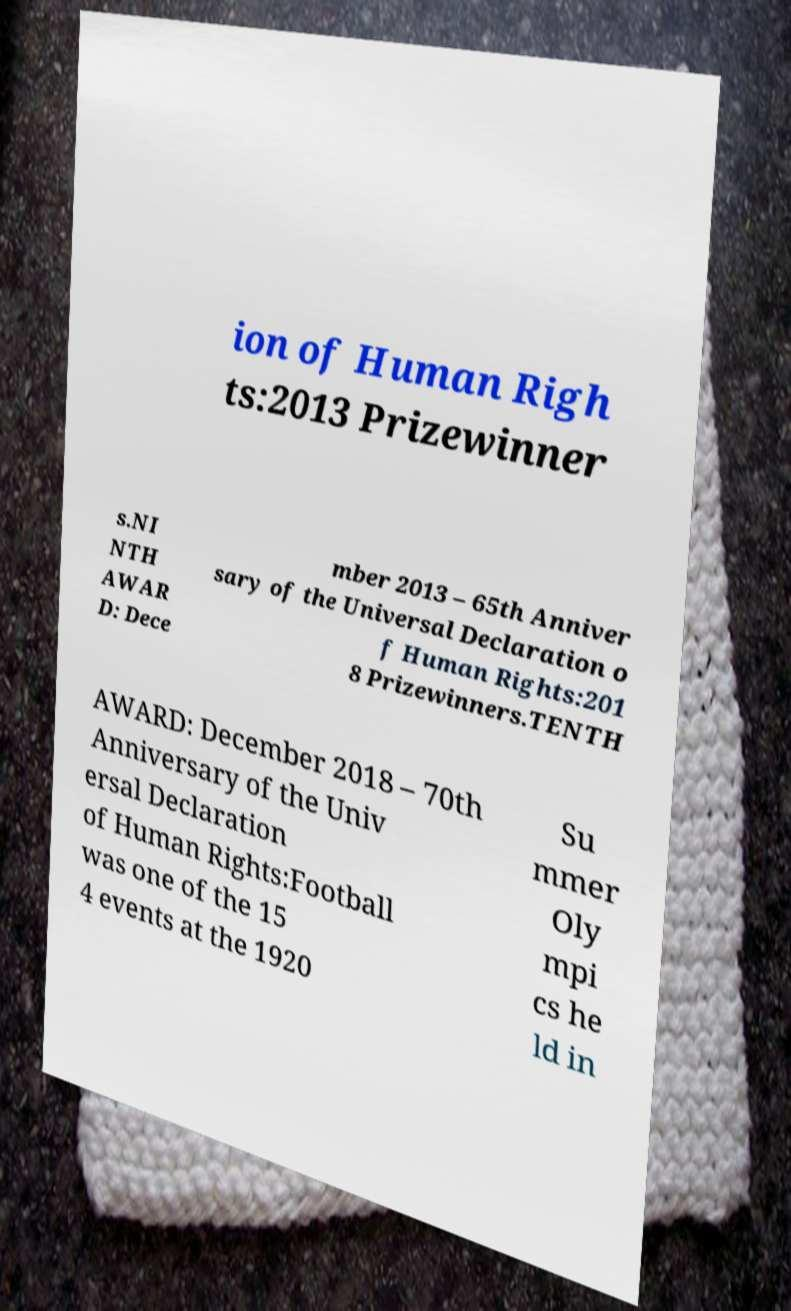Could you assist in decoding the text presented in this image and type it out clearly? ion of Human Righ ts:2013 Prizewinner s.NI NTH AWAR D: Dece mber 2013 – 65th Anniver sary of the Universal Declaration o f Human Rights:201 8 Prizewinners.TENTH AWARD: December 2018 – 70th Anniversary of the Univ ersal Declaration of Human Rights:Football was one of the 15 4 events at the 1920 Su mmer Oly mpi cs he ld in 